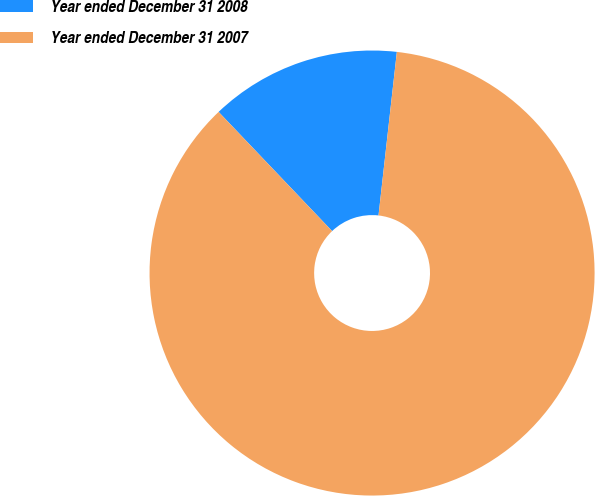Convert chart to OTSL. <chart><loc_0><loc_0><loc_500><loc_500><pie_chart><fcel>Year ended December 31 2008<fcel>Year ended December 31 2007<nl><fcel>13.89%<fcel>86.11%<nl></chart> 